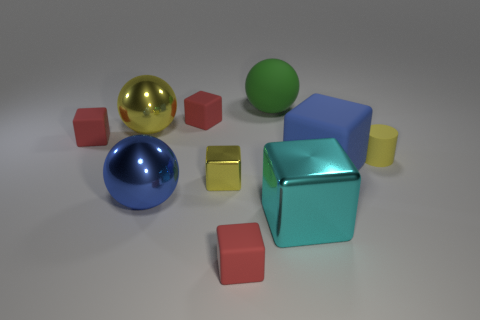How many red blocks must be subtracted to get 1 red blocks? 2 Subtract all blue spheres. How many red cubes are left? 3 Subtract all yellow blocks. How many blocks are left? 5 Subtract all tiny yellow blocks. How many blocks are left? 5 Subtract 1 blocks. How many blocks are left? 5 Subtract all brown blocks. Subtract all cyan spheres. How many blocks are left? 6 Subtract all blocks. How many objects are left? 4 Add 1 large yellow things. How many large yellow things exist? 2 Subtract 0 cyan cylinders. How many objects are left? 10 Subtract all small red rubber things. Subtract all large green matte spheres. How many objects are left? 6 